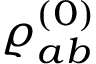Convert formula to latex. <formula><loc_0><loc_0><loc_500><loc_500>\varrho _ { a b } ^ { ( 0 ) }</formula> 